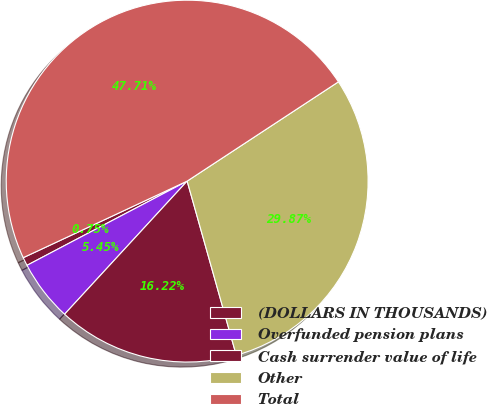Convert chart to OTSL. <chart><loc_0><loc_0><loc_500><loc_500><pie_chart><fcel>(DOLLARS IN THOUSANDS)<fcel>Overfunded pension plans<fcel>Cash surrender value of life<fcel>Other<fcel>Total<nl><fcel>0.75%<fcel>5.45%<fcel>16.22%<fcel>29.87%<fcel>47.71%<nl></chart> 